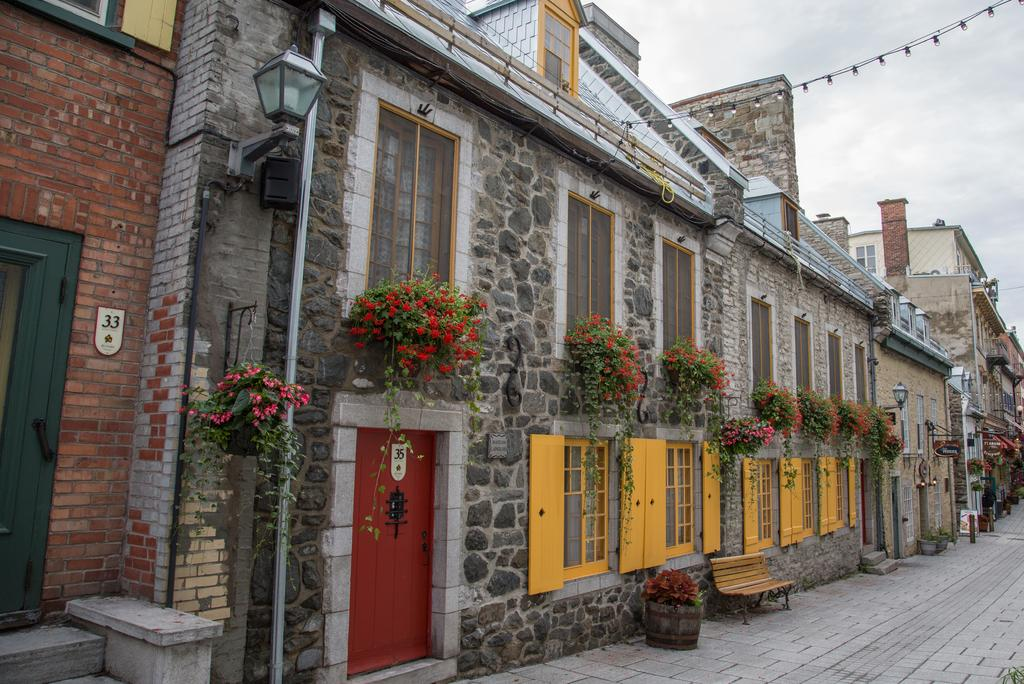What is the main feature of the image? There is a road in the image. What can be seen beside the road? There is a horse and rider beside the road. What type of structures are present in the image? There are buildings in the image. What architectural elements can be observed on the buildings? Doors and windows are visible in the image. Are there any plants in the image? Yes, there are potted plants in the image. Is there any lighting fixture in the image? Yes, a lamp is attached to a wall in the image. What can be seen in the sky in the image? The sky is visible in the image. Can you describe the lipstick shade the fairies are wearing in the image? There are no fairies present in the image, so it is not possible to describe their lipstick shade. 